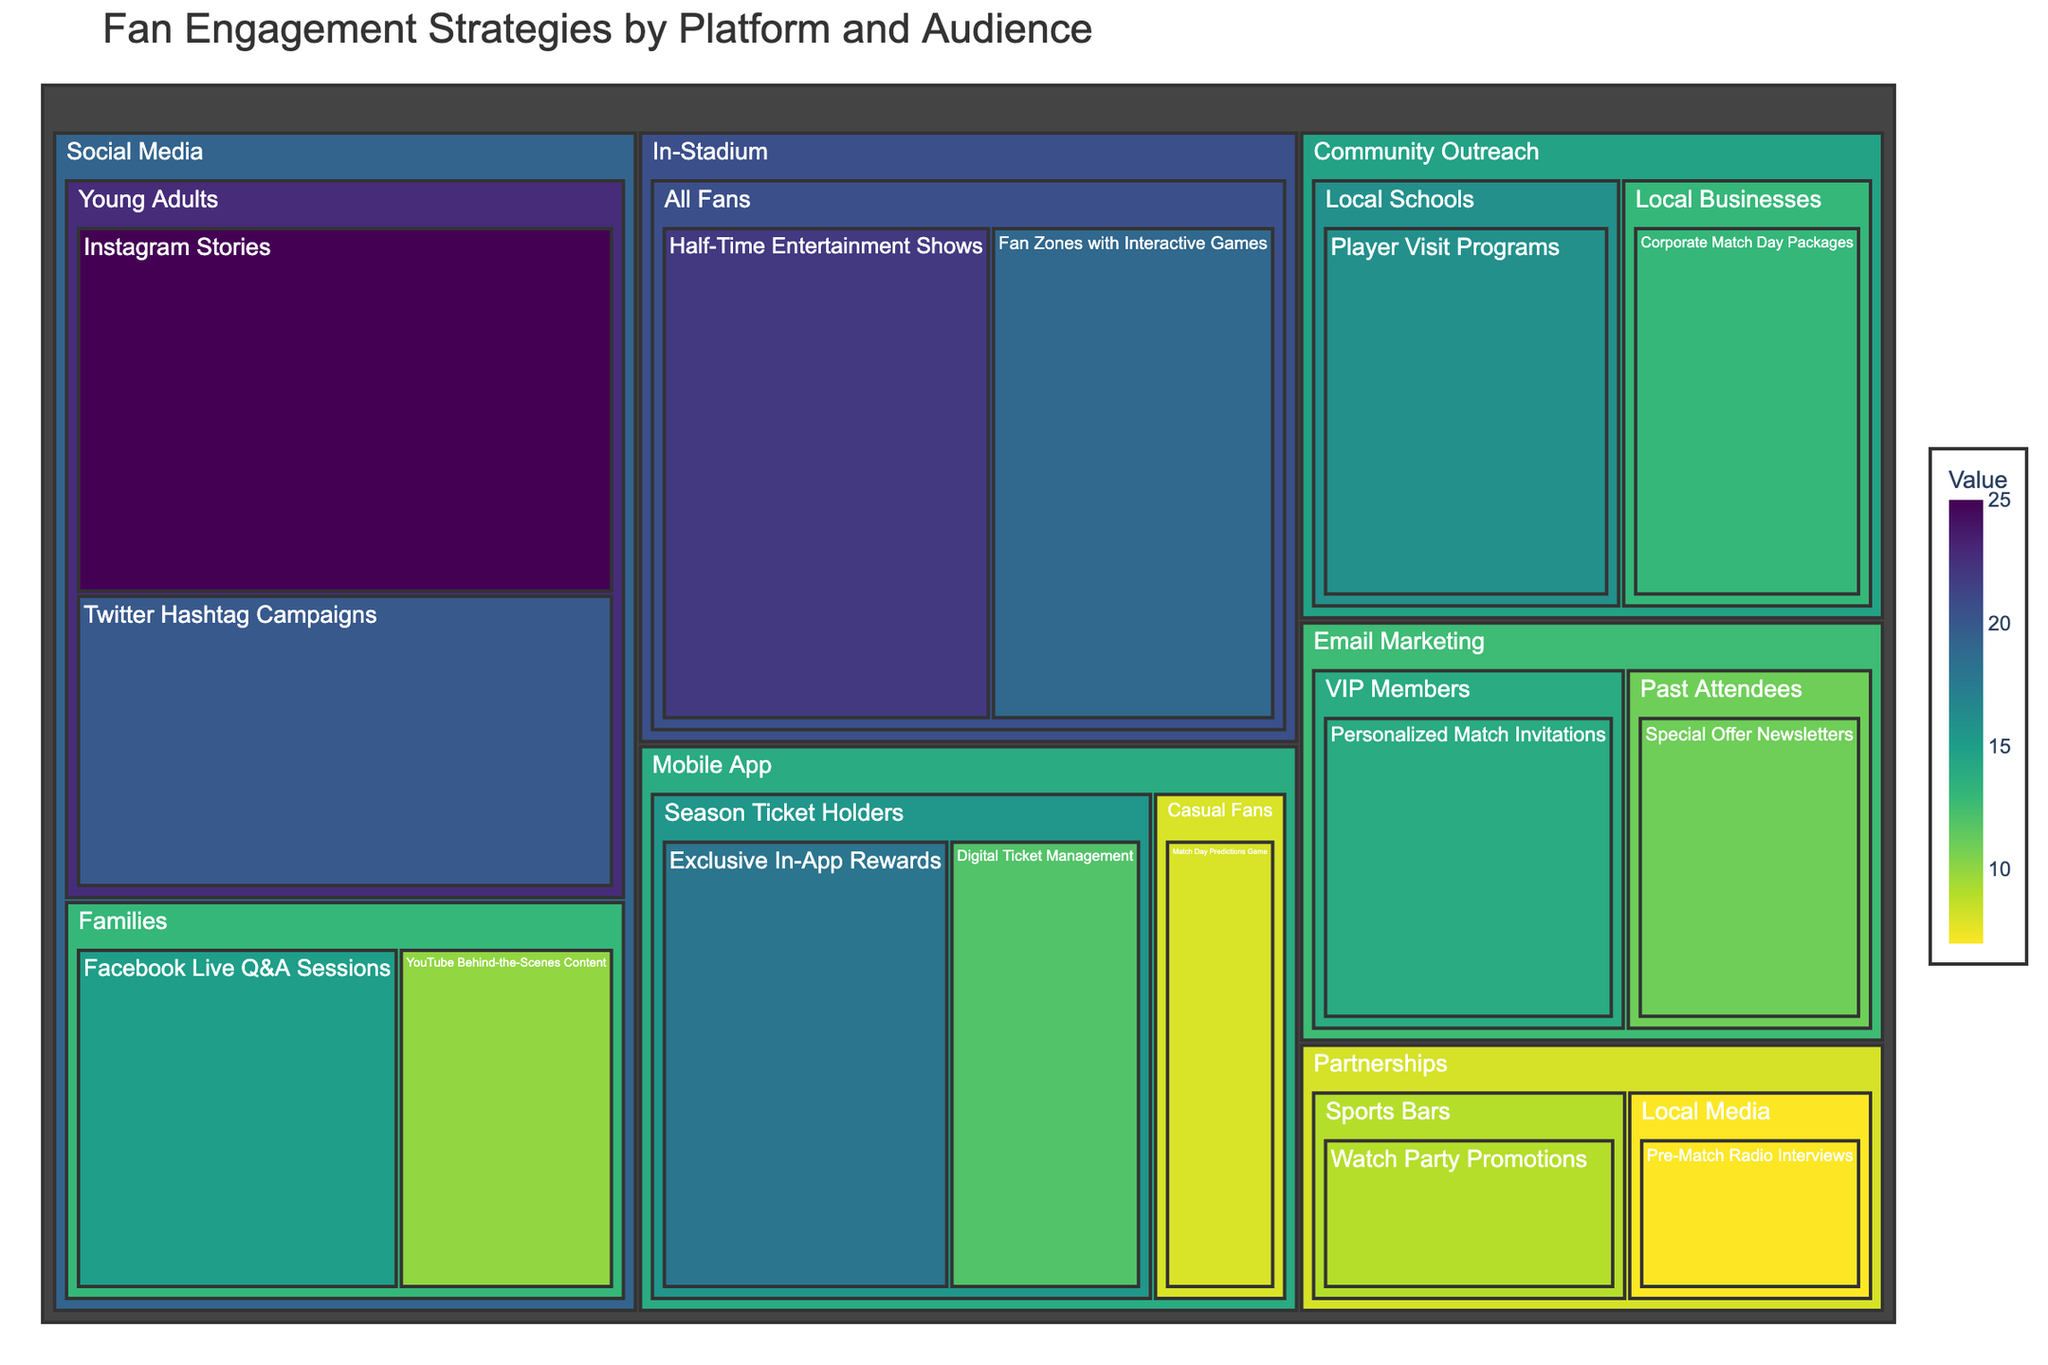What is the title of the Treemap? The title of a plot is generally placed at the top and provides an overview of the content. In this case, the title would be descriptive of the plot's contents, which are "Fan Engagement Strategies by Platform and Audience."
Answer: Fan Engagement Strategies by Platform and Audience What are the platforms listed in the Treemap? Platforms are the top-level categories in the Treemap, usually represented as the largest segments, including Social Media, Mobile App, Email Marketing, In-Stadium, Community Outreach, and Partnerships.
Answer: Social Media, Mobile App, Email Marketing, In-Stadium, Community Outreach, Partnerships What is the strategy with the highest value and what is its value? The strategy with the highest value is visualized as the largest block in the Treemap. The largest block is "Instagram Stories" under "Social Media" and "Young Adults" with a value of 25.
Answer: Instagram Stories, 25 How many fan engagement strategies target "Families" within the "Social Media" platform? Within the "Social Media" segment, you need to identify segments labeled "Families" which include "Facebook Live Q&A Sessions" and "YouTube Behind-the-Scenes Content." Count these segments.
Answer: 2 What is the combined value of fan engagement strategies for "Season Ticket Holders" under the "Mobile App" platform? Add the values of the strategies listed under "Mobile App" targeting "Season Ticket Holders," which are "Exclusive In-App Rewards" with 18 and "Digital Ticket Management" with 12. The sum is 18 + 12 = 30.
Answer: 30 Which target audience has the highest combined value of fan engagement strategies under the "Social Media" platform? Sum the values of strategies under each target audience in the "Social Media" segment. "Young Adults" has "Instagram Stories" (25) and "Twitter Hashtag Campaigns" (20) summing to 45. "Families" has "Facebook Live Q&A Sessions" (15) and "YouTube Behind-the-Scenes Content" (10) summing to 25. Thus, the highest combined value is for "Young Adults."
Answer: Young Adults Which platform has the least number of strategies listed and how many are there? Count the number of segments within each platform. "Partnerships" has "Watch Party Promotions" and "Pre-Match Radio Interviews," amounting to 2 strategies, which is the least.
Answer: Partnerships, 2 What is the value difference between "Half-Time Entertainment Shows" and "Fan Zones with Interactive Games" under the "In-Stadium" platform? Find the values of both strategies and subtract the smaller value from the larger. "Half-Time Entertainment Shows" has 22 and "Fan Zones with Interactive Games" has 19. The difference is 22 - 19 = 3.
Answer: 3 What is the average value of all strategies under "Community Outreach"? Add the values of strategies under "Community Outreach," which are "Player Visit Programs" (16) and "Corporate Match Day Packages" (13). The sum is 16 + 13 = 29. There are 2 strategies, so divide the sum by 2: 29 / 2 = 14.5.
Answer: 14.5 Which strategy targeting "VIP Members" is visualized in the Treemap? Locate the segment under "Email Marketing" targeting "VIP Members" and identify the strategy. The strategy listed under "VIP Members" is "Personalized Match Invitations."
Answer: Personalized Match Invitations 